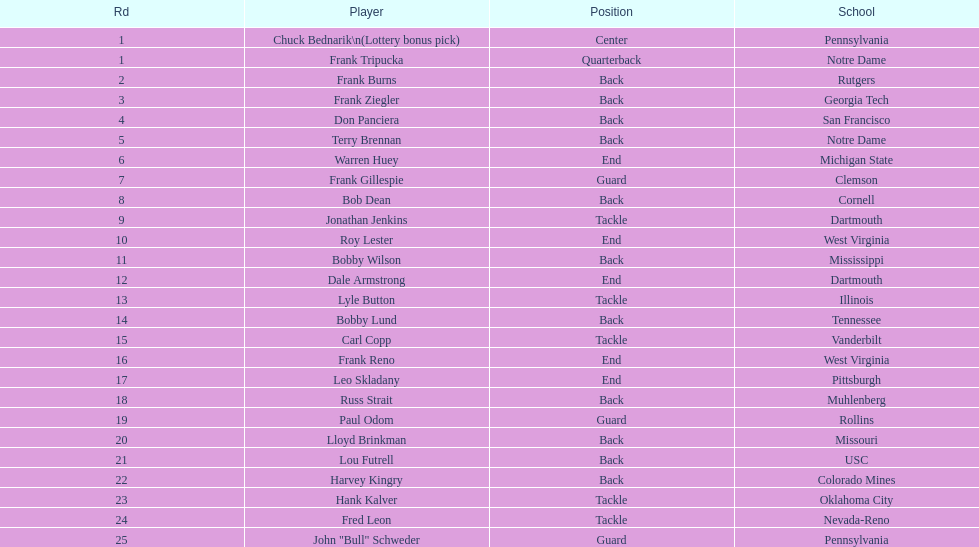What was the position that most of the players had? Back. 